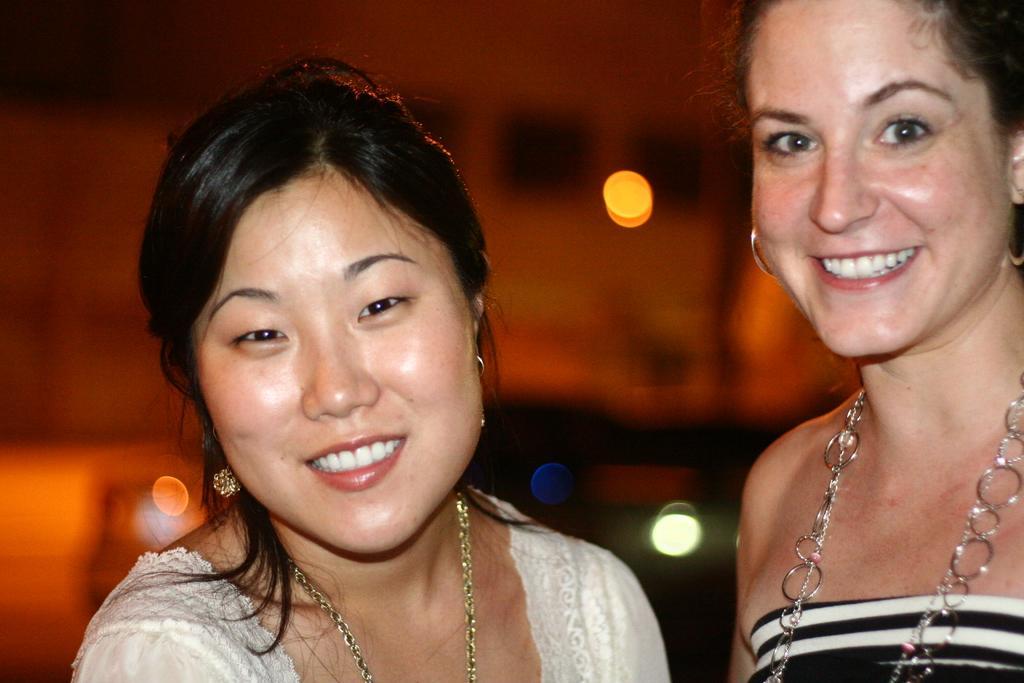Please provide a concise description of this image. In the image there are two women in the front smiling, they both wearing necklace and ear rings and the background is blurry. 